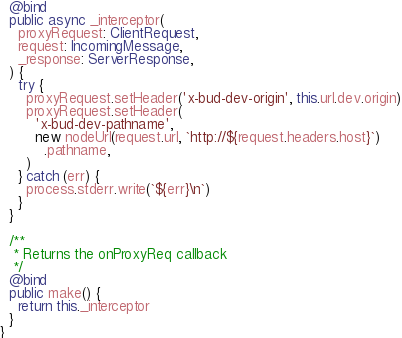Convert code to text. <code><loc_0><loc_0><loc_500><loc_500><_TypeScript_>  @bind
  public async _interceptor(
    proxyRequest: ClientRequest,
    request: IncomingMessage,
    _response: ServerResponse,
  ) {
    try {
      proxyRequest.setHeader('x-bud-dev-origin', this.url.dev.origin)
      proxyRequest.setHeader(
        'x-bud-dev-pathname',
        new nodeUrl(request.url, `http://${request.headers.host}`)
          .pathname,
      )
    } catch (err) {
      process.stderr.write(`${err}\n`)
    }
  }

  /**
   * Returns the onProxyReq callback
   */
  @bind
  public make() {
    return this._interceptor
  }
}
</code> 